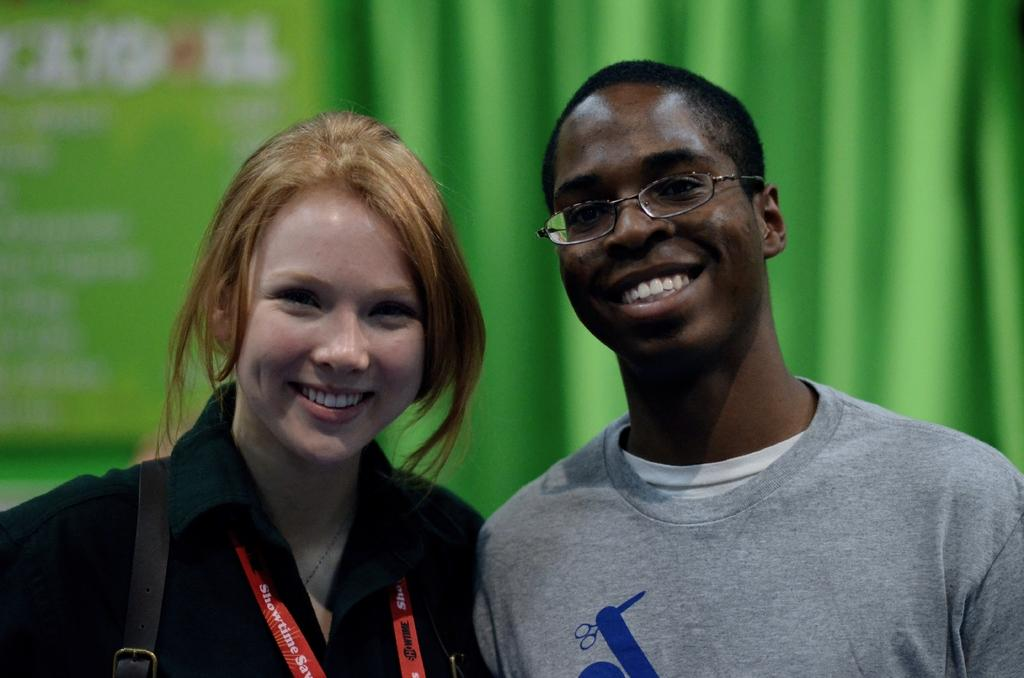Who are the people in the center of the image? There is a lady and a man in the center of the image. What are the lady and the man doing? The lady and the man are standing and smiling. What can be seen in the background of the image? There is a curtain in the background of the image. What type of drink is the lady holding in the image? There is no drink visible in the image; the lady and the man are not holding any objects. 